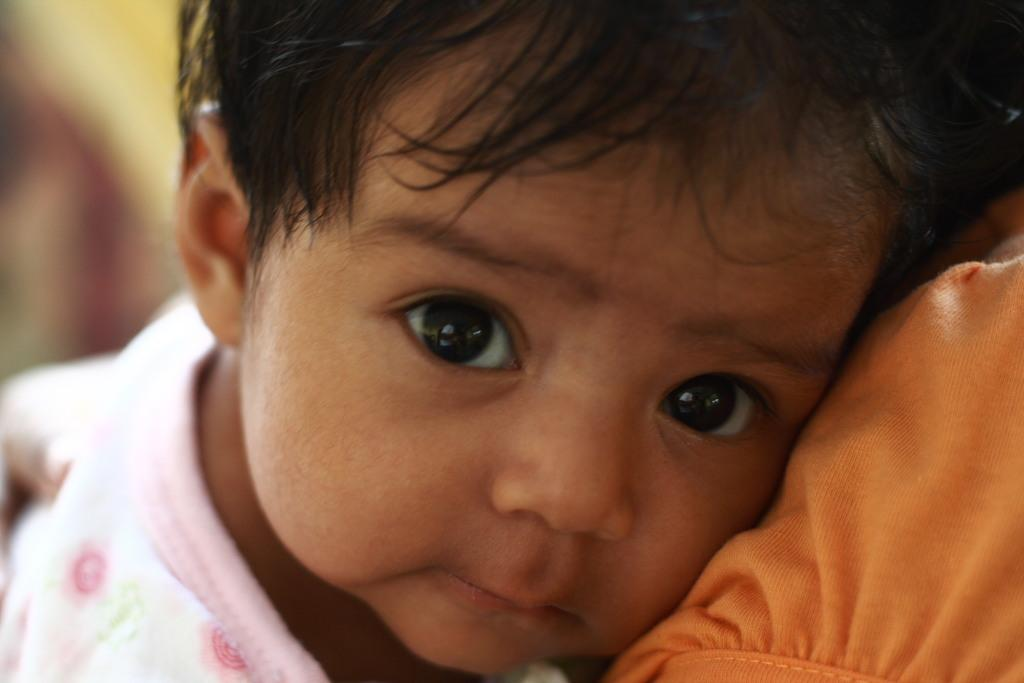Who is the main subject in the image? There is a little girl in the image. What is the girl wearing? The girl is wearing a pink and white dress. Can you describe any other objects or elements in the image? There is an orange color cloth in the image. What type of noise can be heard coming from the lizards in the image? There are no lizards present in the image, so it is not possible to determine what type of noise they might make. 